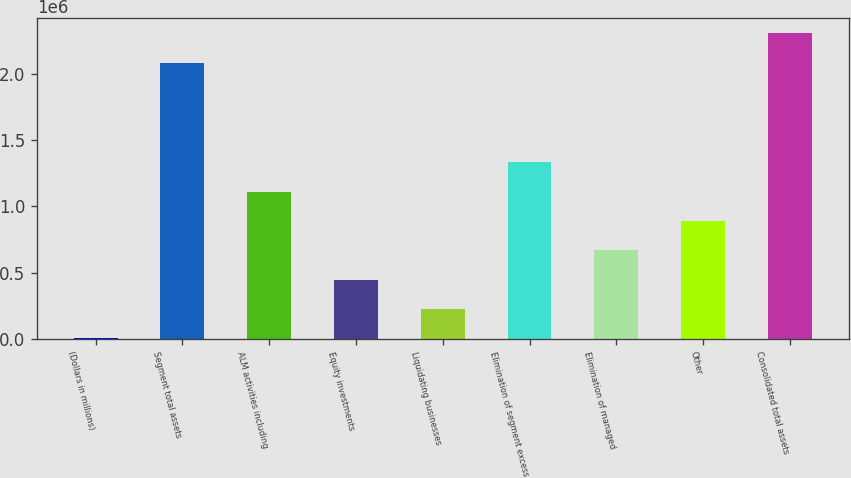<chart> <loc_0><loc_0><loc_500><loc_500><bar_chart><fcel>(Dollars in millions)<fcel>Segment total assets<fcel>ALM activities including<fcel>Equity investments<fcel>Liquidating businesses<fcel>Elimination of segment excess<fcel>Elimination of managed<fcel>Other<fcel>Consolidated total assets<nl><fcel>2009<fcel>2.08592e+06<fcel>1.11265e+06<fcel>446267<fcel>224138<fcel>1.33478e+06<fcel>668396<fcel>890525<fcel>2.30805e+06<nl></chart> 